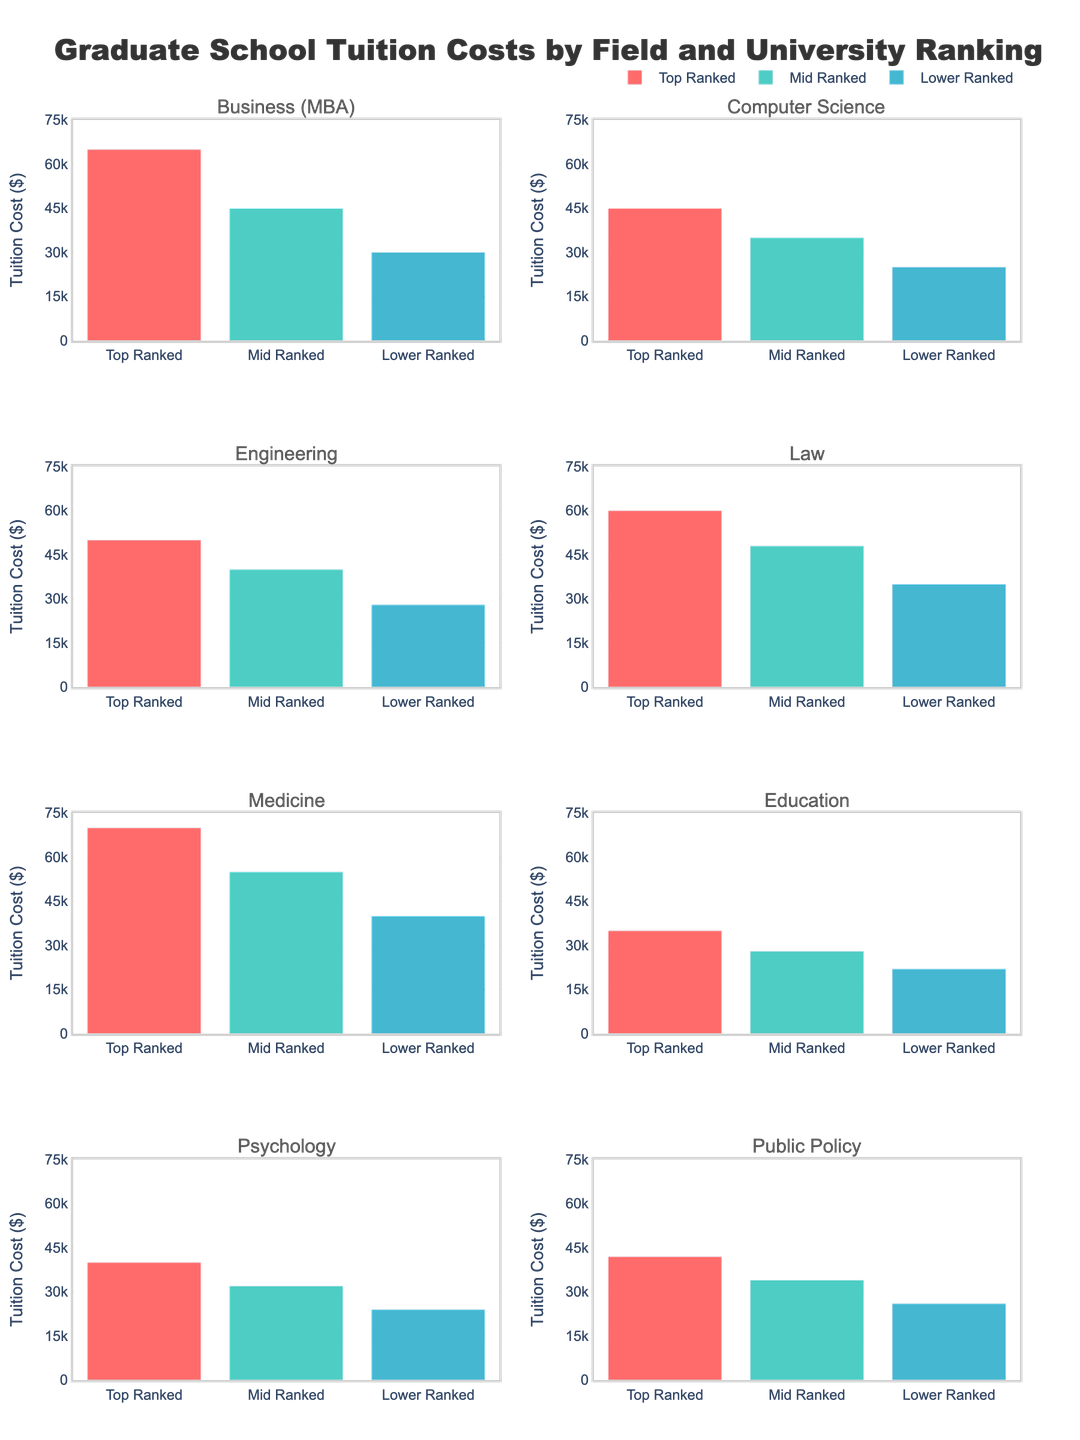What is the title of the figure? The title of the figure is located at the top and it reads 'Programming Language Popularity Trends (2013-2023)'.
Answer: Programming Language Popularity Trends (2013-2023) How many subplots are within the figure grid? By observing the figure, one can count multiple small plots arranged in a grid format. There are 3 rows and 4 columns, making a total of 12 subplots.
Answer: 12 Which programming language had the highest increase in popularity from 2013 to 2023? Looking at each subplot, compare the starting and ending values for each language. Python starts at 7.2% in 2013 and rises to 18.5% in 2023, which is the highest increase.
Answer: Python What was Java's popularity in 2015? Referring to the subplot for Java, the value in 2015 can be read directly from the plot which is at approximately 17.8%.
Answer: 17.8% Compare the trends of Ruby and Go between 2015 and 2023. Which one shows a larger growth? Ruby starts at 3.8% in 2015 and decreases to 1.9% in 2023, whereas Go starts at 0.4% in 2015 and increases to 2.4% in 2023. Go shows larger growth compared to Ruby.
Answer: Go What is the overall trend for TypeScript's popularity from 2013 to 2023? Observing the TypeScript subplot, its popularity increases consistently every year from 0.3% in 2013 to 3.8% in 2023, indicating a steady upward trend.
Answer: Steady upward trend Which year did Rust’s popularity exceed 1% for the first time? Checking the values in Rust’s subplot, the value exceeds 1% for the first time in 2021.
Answer: 2021 Calculate the average popularity of C# over the given period. By adding the C# values (6.8 + 6.5 + 6.2 + 5.9 + 5.6 + 5.3) = 36.3 and dividing by the number of years (6), the average popularity is 36.3/6 approximately 6.05%.
Answer: 6.05% Which languages show a downward trend in popularity from 2013 to 2023? By observing each subplot, Java, C#, C++, and Ruby show a decrease in their values over this period, indicating a downward trend.
Answer: Java, C#, C++, Ruby What value does Python's popularity reach in 2023, and how does it compare to its value in 2013? In the Python subplot, the value in 2023 is 18.5%, and in 2013, it was 7.2%. The difference is 18.5% - 7.2% = 11.3%, showing significant growth.
Answer: Reaches 18.5%; increased by 11.3% 